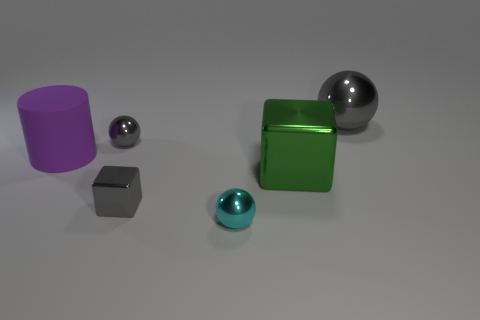Subtract all small gray balls. How many balls are left? 2 Subtract all brown cylinders. How many gray spheres are left? 2 Subtract 1 balls. How many balls are left? 2 Add 3 blue metal spheres. How many objects exist? 9 Subtract all blocks. How many objects are left? 4 Subtract all blue balls. Subtract all purple cylinders. How many balls are left? 3 Add 3 small red shiny spheres. How many small red shiny spheres exist? 3 Subtract 1 cyan balls. How many objects are left? 5 Subtract all gray cubes. Subtract all purple objects. How many objects are left? 4 Add 2 tiny metallic spheres. How many tiny metallic spheres are left? 4 